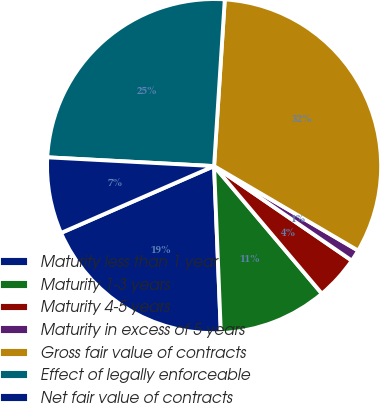<chart> <loc_0><loc_0><loc_500><loc_500><pie_chart><fcel>Maturity less than 1 year<fcel>Maturity 1-3 years<fcel>Maturity 4-5 years<fcel>Maturity in excess of 5 years<fcel>Gross fair value of contracts<fcel>Effect of legally enforceable<fcel>Net fair value of contracts<nl><fcel>19.09%<fcel>10.52%<fcel>4.26%<fcel>1.13%<fcel>32.42%<fcel>25.18%<fcel>7.39%<nl></chart> 